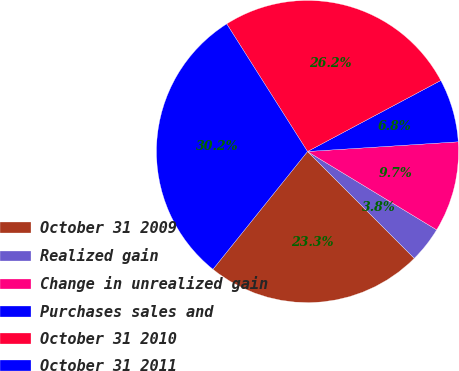Convert chart. <chart><loc_0><loc_0><loc_500><loc_500><pie_chart><fcel>October 31 2009<fcel>Realized gain<fcel>Change in unrealized gain<fcel>Purchases sales and<fcel>October 31 2010<fcel>October 31 2011<nl><fcel>23.26%<fcel>3.83%<fcel>9.7%<fcel>6.77%<fcel>26.19%<fcel>30.25%<nl></chart> 